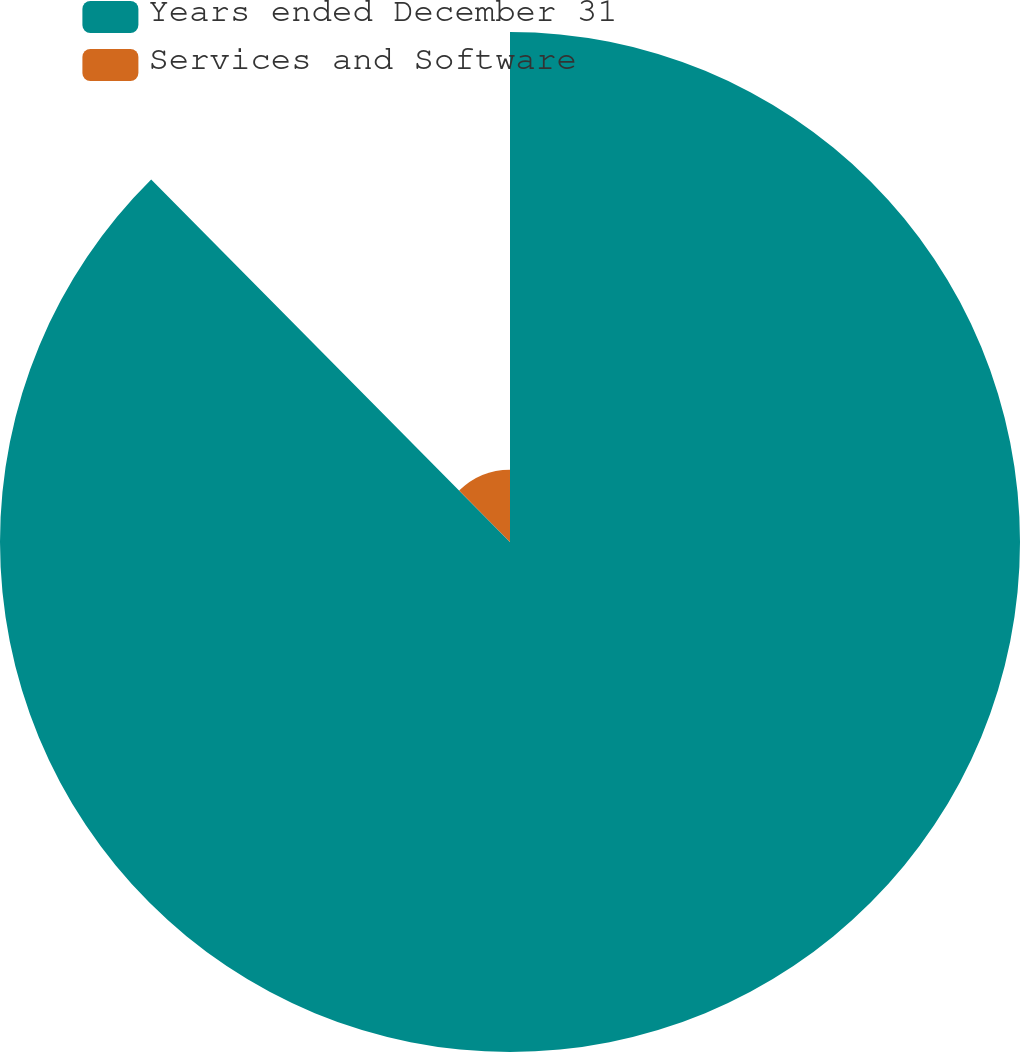<chart> <loc_0><loc_0><loc_500><loc_500><pie_chart><fcel>Years ended December 31<fcel>Services and Software<nl><fcel>87.58%<fcel>12.42%<nl></chart> 